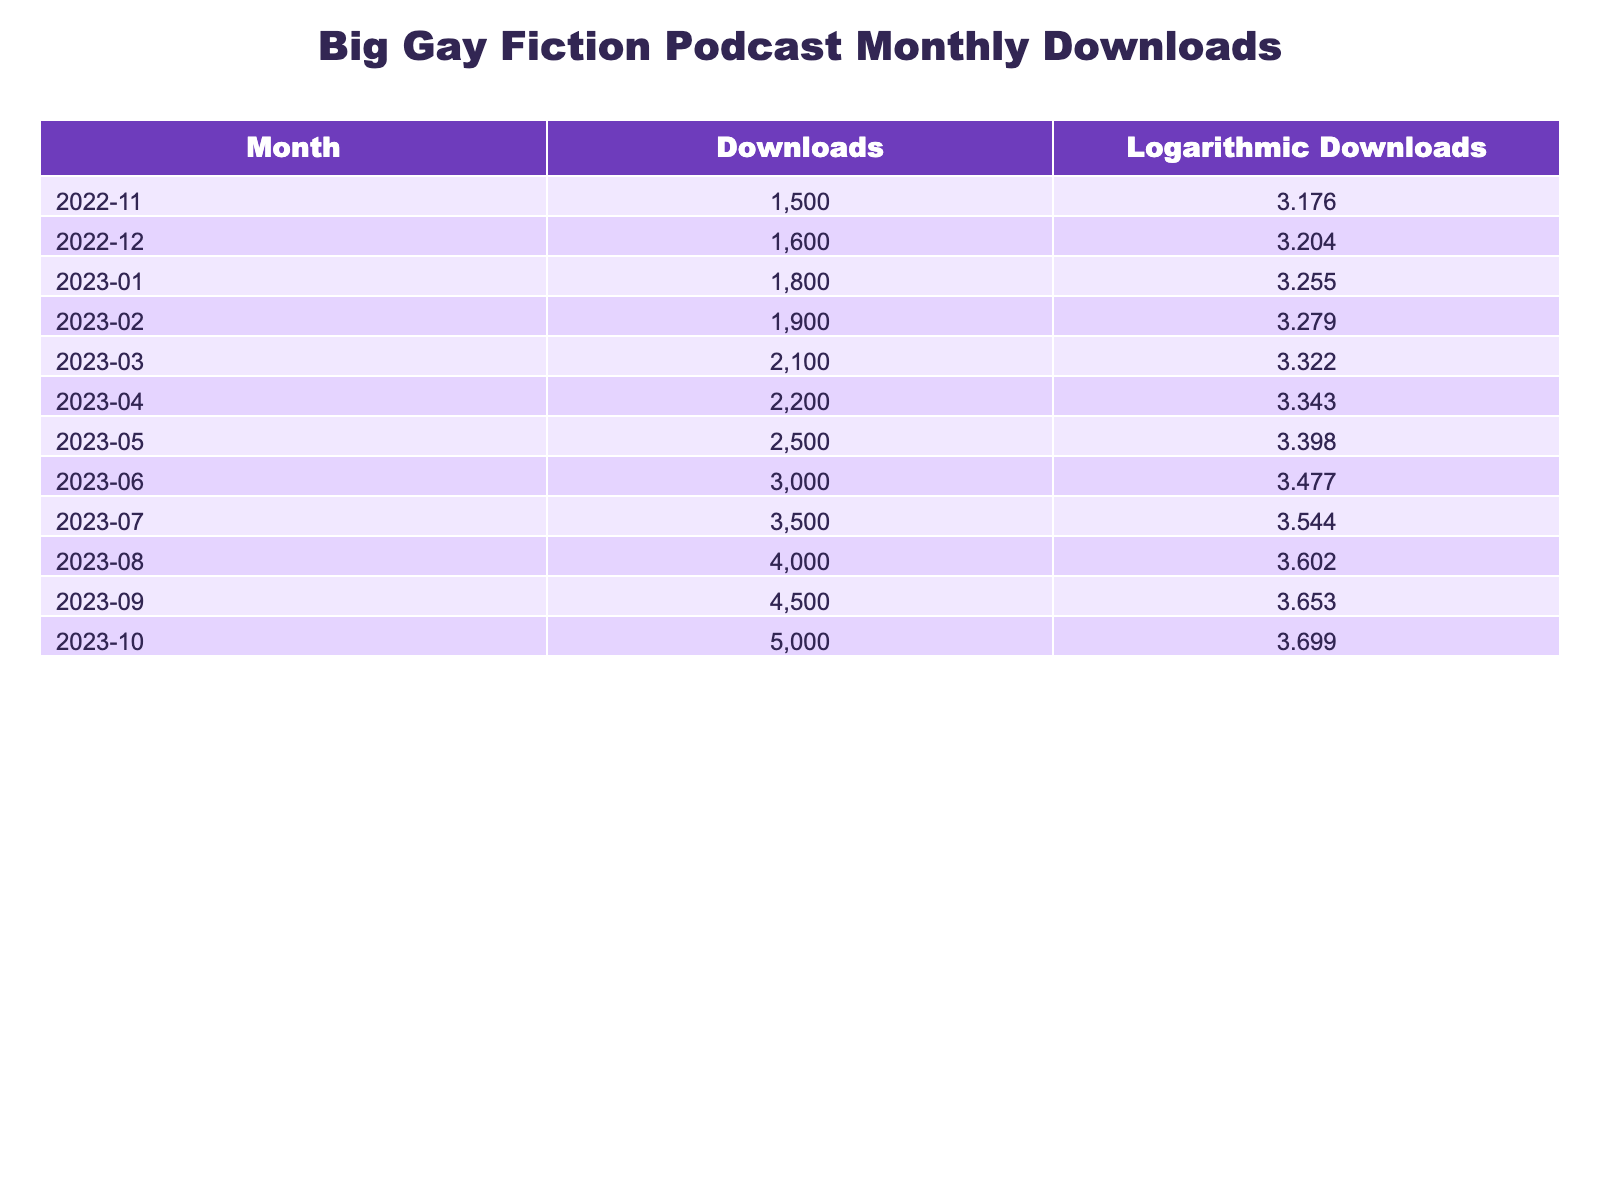What was the total number of downloads in March 2023? The table indicates that in March 2023, the downloads were 2100. Thus, the value is directly found in the row for that month.
Answer: 2100 What month had the highest number of logarithmic downloads? By examining the logarithmic downloads column, October 2023 has the highest value at 3.699007. Therefore, it corresponds to October.
Answer: October 2023 What is the difference between the downloads in July 2023 and January 2023? From the table, July 2023 had 3500 downloads and January 2023 had 1800 downloads. The difference is calculated as 3500 - 1800 = 1700.
Answer: 1700 How many downloads were there on average over the last year? Adding the total downloads from all months gives 1500 + 1600 + 1800 + 1900 + 2100 + 2200 + 2500 + 3000 + 3500 + 4000 + 4500 + 5000 = 30000. Dividing by the total number of months (12) gives 30000 / 12 = 2500.
Answer: 2500 Is it true that the downloads increased every month from November 2022 to October 2023? Checking the table, each month's downloads are higher than the previous month, confirming that downloads consistently increased. Thus, the statement is true.
Answer: Yes Which month saw an increase of 400 downloads compared to the previous month? Looking at the differences month by month, an increase of 400 downloads can be seen from April 2023 (2200) to May 2023 (2500). Hence, May is the month that fits this criterion.
Answer: May 2023 Which two months had the closest number of downloads? By comparing the downloads month by month, the smallest difference is between December 2022 (1600) and November 2022 (1500), which is 100. Thus, these are the closest months in terms of downloads.
Answer: November 2022 and December 2022 What is the total logarithmic downloads for the first half of the year? The logarithmic values for the first half are 3.176091 (November) + 3.204120 (December) + 3.255273 (January) + 3.278754 (February) + 3.322219 (March) + 3.343408 (April) = 19.579865. Therefore, that is the total for these months.
Answer: 19.579865 